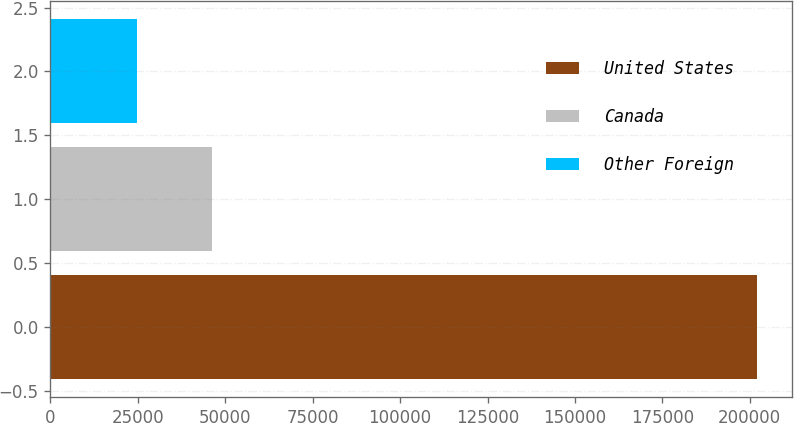<chart> <loc_0><loc_0><loc_500><loc_500><bar_chart><fcel>United States<fcel>Canada<fcel>Other Foreign<nl><fcel>202067<fcel>46191<fcel>24885<nl></chart> 